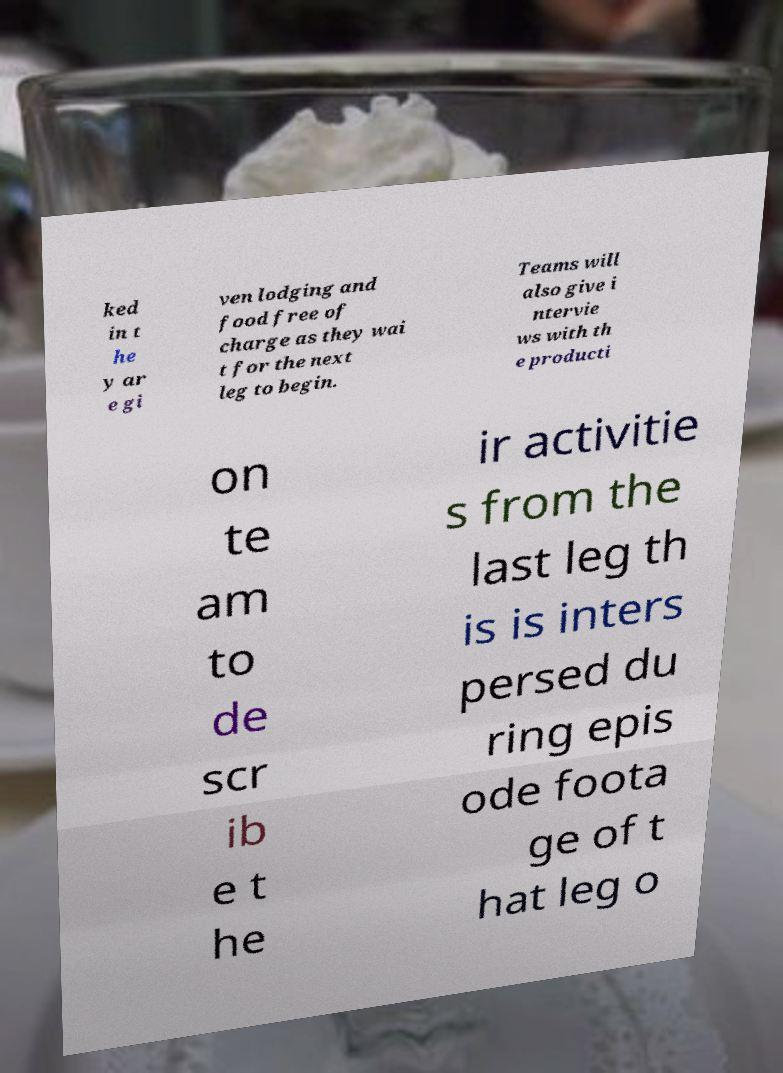What messages or text are displayed in this image? I need them in a readable, typed format. ked in t he y ar e gi ven lodging and food free of charge as they wai t for the next leg to begin. Teams will also give i ntervie ws with th e producti on te am to de scr ib e t he ir activitie s from the last leg th is is inters persed du ring epis ode foota ge of t hat leg o 